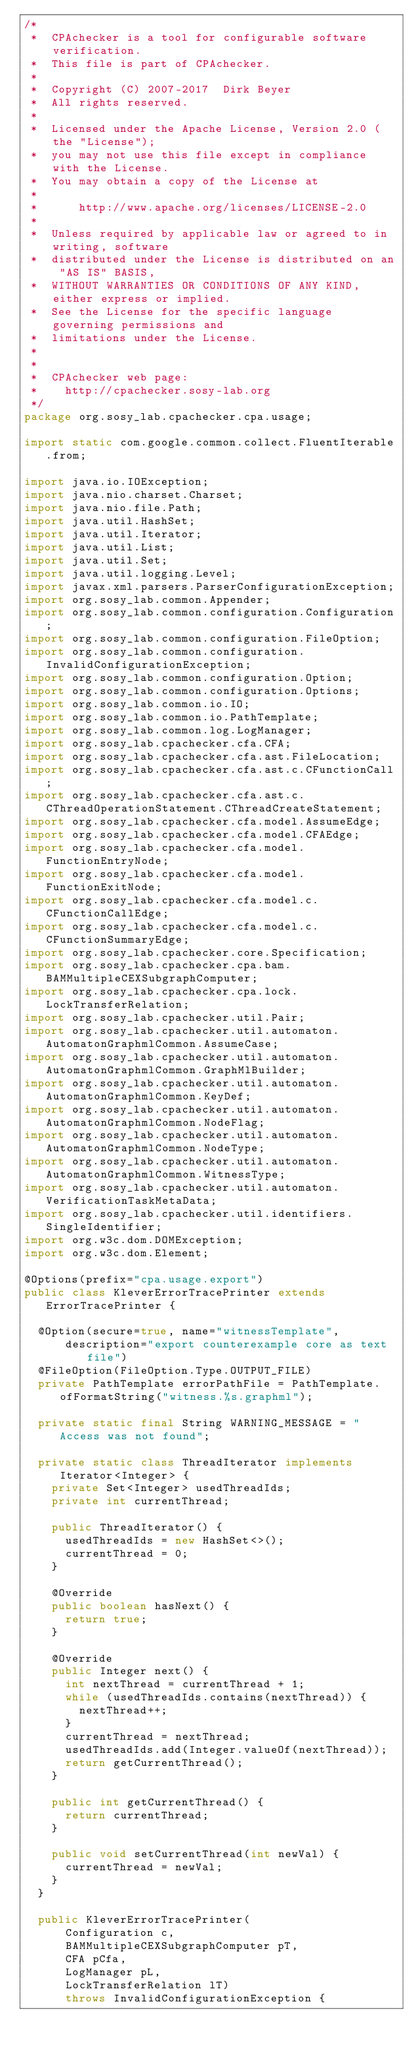<code> <loc_0><loc_0><loc_500><loc_500><_Java_>/*
 *  CPAchecker is a tool for configurable software verification.
 *  This file is part of CPAchecker.
 *
 *  Copyright (C) 2007-2017  Dirk Beyer
 *  All rights reserved.
 *
 *  Licensed under the Apache License, Version 2.0 (the "License");
 *  you may not use this file except in compliance with the License.
 *  You may obtain a copy of the License at
 *
 *      http://www.apache.org/licenses/LICENSE-2.0
 *
 *  Unless required by applicable law or agreed to in writing, software
 *  distributed under the License is distributed on an "AS IS" BASIS,
 *  WITHOUT WARRANTIES OR CONDITIONS OF ANY KIND, either express or implied.
 *  See the License for the specific language governing permissions and
 *  limitations under the License.
 *
 *
 *  CPAchecker web page:
 *    http://cpachecker.sosy-lab.org
 */
package org.sosy_lab.cpachecker.cpa.usage;

import static com.google.common.collect.FluentIterable.from;

import java.io.IOException;
import java.nio.charset.Charset;
import java.nio.file.Path;
import java.util.HashSet;
import java.util.Iterator;
import java.util.List;
import java.util.Set;
import java.util.logging.Level;
import javax.xml.parsers.ParserConfigurationException;
import org.sosy_lab.common.Appender;
import org.sosy_lab.common.configuration.Configuration;
import org.sosy_lab.common.configuration.FileOption;
import org.sosy_lab.common.configuration.InvalidConfigurationException;
import org.sosy_lab.common.configuration.Option;
import org.sosy_lab.common.configuration.Options;
import org.sosy_lab.common.io.IO;
import org.sosy_lab.common.io.PathTemplate;
import org.sosy_lab.common.log.LogManager;
import org.sosy_lab.cpachecker.cfa.CFA;
import org.sosy_lab.cpachecker.cfa.ast.FileLocation;
import org.sosy_lab.cpachecker.cfa.ast.c.CFunctionCall;
import org.sosy_lab.cpachecker.cfa.ast.c.CThreadOperationStatement.CThreadCreateStatement;
import org.sosy_lab.cpachecker.cfa.model.AssumeEdge;
import org.sosy_lab.cpachecker.cfa.model.CFAEdge;
import org.sosy_lab.cpachecker.cfa.model.FunctionEntryNode;
import org.sosy_lab.cpachecker.cfa.model.FunctionExitNode;
import org.sosy_lab.cpachecker.cfa.model.c.CFunctionCallEdge;
import org.sosy_lab.cpachecker.cfa.model.c.CFunctionSummaryEdge;
import org.sosy_lab.cpachecker.core.Specification;
import org.sosy_lab.cpachecker.cpa.bam.BAMMultipleCEXSubgraphComputer;
import org.sosy_lab.cpachecker.cpa.lock.LockTransferRelation;
import org.sosy_lab.cpachecker.util.Pair;
import org.sosy_lab.cpachecker.util.automaton.AutomatonGraphmlCommon.AssumeCase;
import org.sosy_lab.cpachecker.util.automaton.AutomatonGraphmlCommon.GraphMlBuilder;
import org.sosy_lab.cpachecker.util.automaton.AutomatonGraphmlCommon.KeyDef;
import org.sosy_lab.cpachecker.util.automaton.AutomatonGraphmlCommon.NodeFlag;
import org.sosy_lab.cpachecker.util.automaton.AutomatonGraphmlCommon.NodeType;
import org.sosy_lab.cpachecker.util.automaton.AutomatonGraphmlCommon.WitnessType;
import org.sosy_lab.cpachecker.util.automaton.VerificationTaskMetaData;
import org.sosy_lab.cpachecker.util.identifiers.SingleIdentifier;
import org.w3c.dom.DOMException;
import org.w3c.dom.Element;

@Options(prefix="cpa.usage.export")
public class KleverErrorTracePrinter extends ErrorTracePrinter {

  @Option(secure=true, name="witnessTemplate",
      description="export counterexample core as text file")
  @FileOption(FileOption.Type.OUTPUT_FILE)
  private PathTemplate errorPathFile = PathTemplate.ofFormatString("witness.%s.graphml");

  private static final String WARNING_MESSAGE = "Access was not found";

  private static class ThreadIterator implements Iterator<Integer> {
    private Set<Integer> usedThreadIds;
    private int currentThread;

    public ThreadIterator() {
      usedThreadIds = new HashSet<>();
      currentThread = 0;
    }

    @Override
    public boolean hasNext() {
      return true;
    }

    @Override
    public Integer next() {
      int nextThread = currentThread + 1;
      while (usedThreadIds.contains(nextThread)) {
        nextThread++;
      }
      currentThread = nextThread;
      usedThreadIds.add(Integer.valueOf(nextThread));
      return getCurrentThread();
    }

    public int getCurrentThread() {
      return currentThread;
    }

    public void setCurrentThread(int newVal) {
      currentThread = newVal;
    }
  }

  public KleverErrorTracePrinter(
      Configuration c,
      BAMMultipleCEXSubgraphComputer pT,
      CFA pCfa,
      LogManager pL,
      LockTransferRelation lT)
      throws InvalidConfigurationException {</code> 